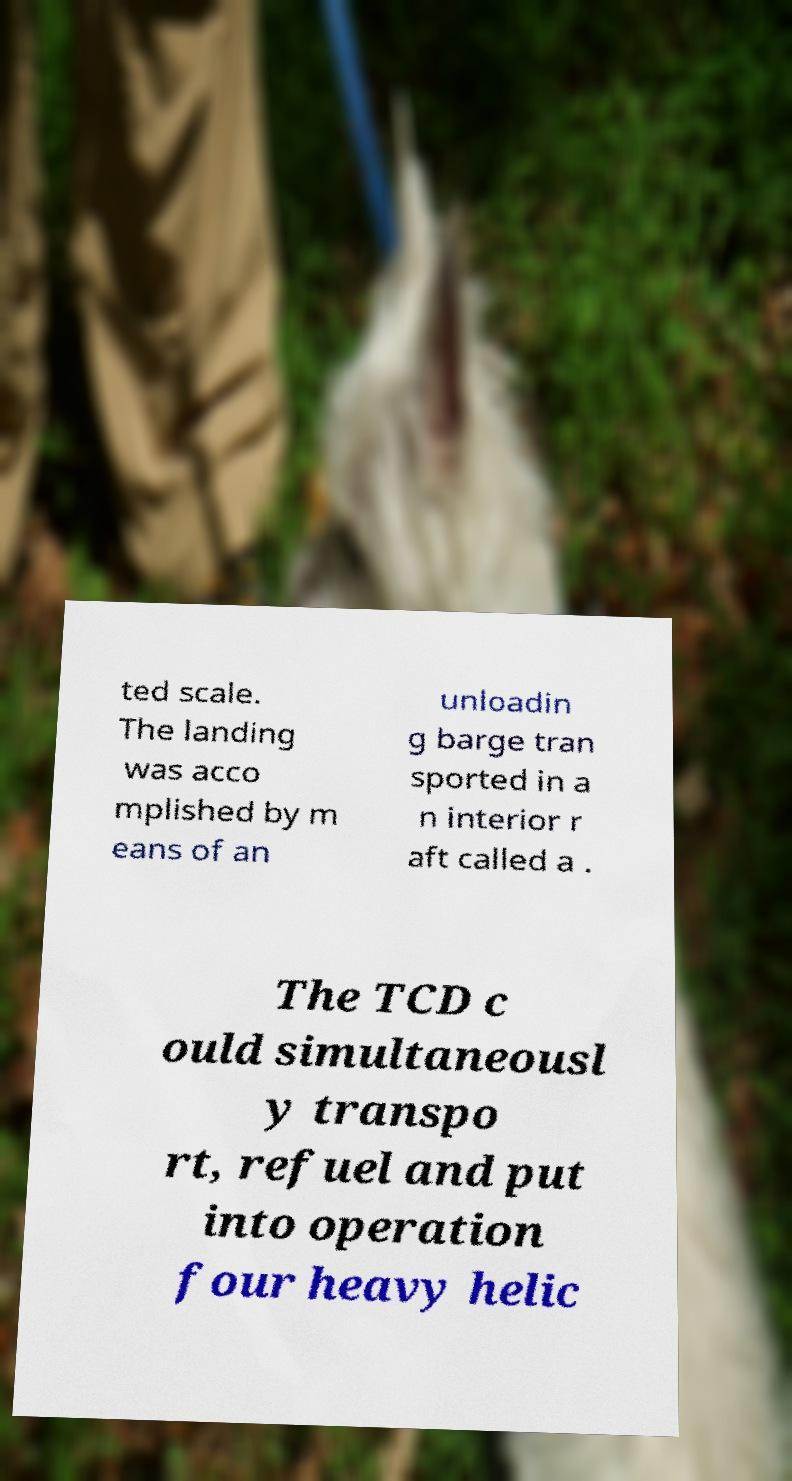I need the written content from this picture converted into text. Can you do that? ted scale. The landing was acco mplished by m eans of an unloadin g barge tran sported in a n interior r aft called a . The TCD c ould simultaneousl y transpo rt, refuel and put into operation four heavy helic 